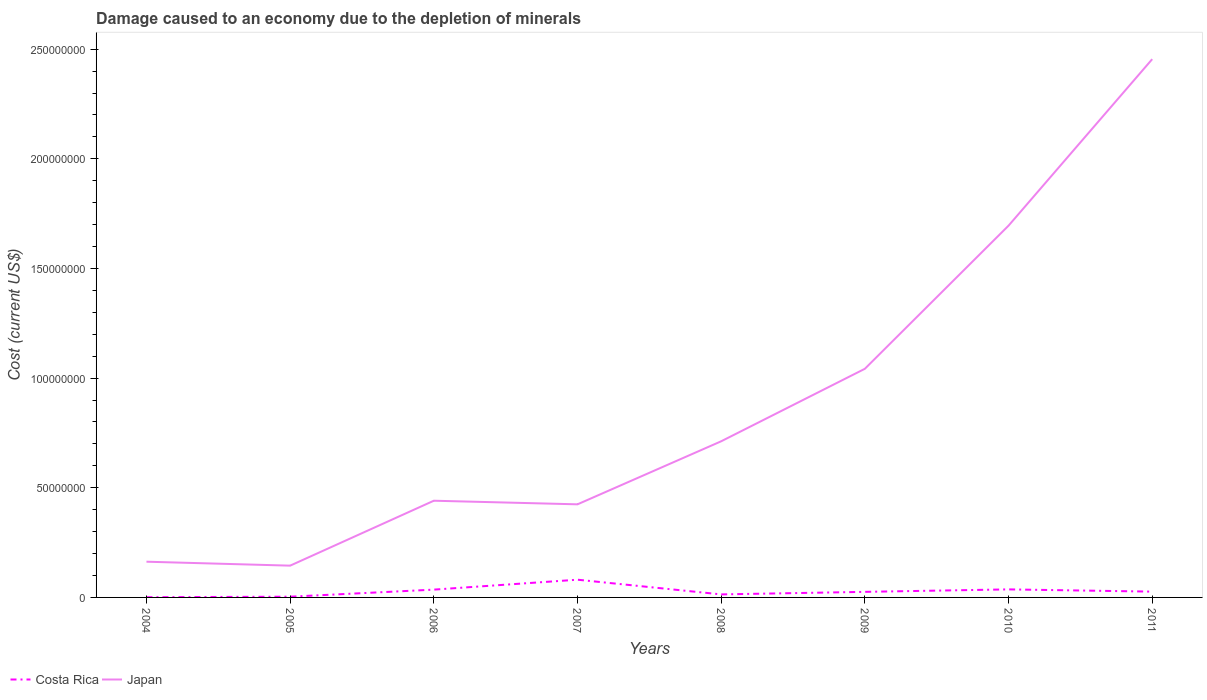Across all years, what is the maximum cost of damage caused due to the depletion of minerals in Costa Rica?
Offer a terse response. 1.03e+05. In which year was the cost of damage caused due to the depletion of minerals in Japan maximum?
Your answer should be very brief. 2005. What is the total cost of damage caused due to the depletion of minerals in Japan in the graph?
Your answer should be very brief. -2.31e+08. What is the difference between the highest and the second highest cost of damage caused due to the depletion of minerals in Japan?
Give a very brief answer. 2.31e+08. What is the difference between the highest and the lowest cost of damage caused due to the depletion of minerals in Japan?
Your answer should be very brief. 3. Is the cost of damage caused due to the depletion of minerals in Japan strictly greater than the cost of damage caused due to the depletion of minerals in Costa Rica over the years?
Offer a terse response. No. How many lines are there?
Offer a terse response. 2. How many years are there in the graph?
Make the answer very short. 8. Are the values on the major ticks of Y-axis written in scientific E-notation?
Keep it short and to the point. No. How many legend labels are there?
Your answer should be compact. 2. What is the title of the graph?
Give a very brief answer. Damage caused to an economy due to the depletion of minerals. Does "Morocco" appear as one of the legend labels in the graph?
Offer a very short reply. No. What is the label or title of the Y-axis?
Offer a terse response. Cost (current US$). What is the Cost (current US$) of Costa Rica in 2004?
Provide a succinct answer. 1.03e+05. What is the Cost (current US$) in Japan in 2004?
Provide a short and direct response. 1.63e+07. What is the Cost (current US$) of Costa Rica in 2005?
Ensure brevity in your answer.  3.34e+05. What is the Cost (current US$) of Japan in 2005?
Give a very brief answer. 1.45e+07. What is the Cost (current US$) of Costa Rica in 2006?
Offer a very short reply. 3.55e+06. What is the Cost (current US$) of Japan in 2006?
Provide a short and direct response. 4.41e+07. What is the Cost (current US$) in Costa Rica in 2007?
Provide a short and direct response. 8.08e+06. What is the Cost (current US$) of Japan in 2007?
Provide a short and direct response. 4.25e+07. What is the Cost (current US$) of Costa Rica in 2008?
Give a very brief answer. 1.38e+06. What is the Cost (current US$) in Japan in 2008?
Make the answer very short. 7.12e+07. What is the Cost (current US$) of Costa Rica in 2009?
Make the answer very short. 2.54e+06. What is the Cost (current US$) of Japan in 2009?
Offer a terse response. 1.04e+08. What is the Cost (current US$) of Costa Rica in 2010?
Your answer should be compact. 3.67e+06. What is the Cost (current US$) in Japan in 2010?
Offer a very short reply. 1.70e+08. What is the Cost (current US$) of Costa Rica in 2011?
Offer a very short reply. 2.64e+06. What is the Cost (current US$) in Japan in 2011?
Keep it short and to the point. 2.45e+08. Across all years, what is the maximum Cost (current US$) of Costa Rica?
Provide a succinct answer. 8.08e+06. Across all years, what is the maximum Cost (current US$) of Japan?
Ensure brevity in your answer.  2.45e+08. Across all years, what is the minimum Cost (current US$) of Costa Rica?
Offer a very short reply. 1.03e+05. Across all years, what is the minimum Cost (current US$) of Japan?
Provide a short and direct response. 1.45e+07. What is the total Cost (current US$) in Costa Rica in the graph?
Provide a succinct answer. 2.23e+07. What is the total Cost (current US$) of Japan in the graph?
Your response must be concise. 7.08e+08. What is the difference between the Cost (current US$) in Costa Rica in 2004 and that in 2005?
Offer a very short reply. -2.32e+05. What is the difference between the Cost (current US$) of Japan in 2004 and that in 2005?
Your answer should be very brief. 1.80e+06. What is the difference between the Cost (current US$) in Costa Rica in 2004 and that in 2006?
Your answer should be very brief. -3.45e+06. What is the difference between the Cost (current US$) of Japan in 2004 and that in 2006?
Your answer should be very brief. -2.78e+07. What is the difference between the Cost (current US$) of Costa Rica in 2004 and that in 2007?
Make the answer very short. -7.98e+06. What is the difference between the Cost (current US$) in Japan in 2004 and that in 2007?
Your answer should be compact. -2.62e+07. What is the difference between the Cost (current US$) in Costa Rica in 2004 and that in 2008?
Offer a terse response. -1.28e+06. What is the difference between the Cost (current US$) of Japan in 2004 and that in 2008?
Provide a succinct answer. -5.49e+07. What is the difference between the Cost (current US$) in Costa Rica in 2004 and that in 2009?
Offer a terse response. -2.44e+06. What is the difference between the Cost (current US$) in Japan in 2004 and that in 2009?
Offer a very short reply. -8.80e+07. What is the difference between the Cost (current US$) of Costa Rica in 2004 and that in 2010?
Your response must be concise. -3.57e+06. What is the difference between the Cost (current US$) of Japan in 2004 and that in 2010?
Your answer should be very brief. -1.53e+08. What is the difference between the Cost (current US$) in Costa Rica in 2004 and that in 2011?
Make the answer very short. -2.54e+06. What is the difference between the Cost (current US$) of Japan in 2004 and that in 2011?
Keep it short and to the point. -2.29e+08. What is the difference between the Cost (current US$) of Costa Rica in 2005 and that in 2006?
Your answer should be very brief. -3.22e+06. What is the difference between the Cost (current US$) in Japan in 2005 and that in 2006?
Provide a short and direct response. -2.96e+07. What is the difference between the Cost (current US$) in Costa Rica in 2005 and that in 2007?
Your response must be concise. -7.75e+06. What is the difference between the Cost (current US$) of Japan in 2005 and that in 2007?
Give a very brief answer. -2.80e+07. What is the difference between the Cost (current US$) in Costa Rica in 2005 and that in 2008?
Keep it short and to the point. -1.04e+06. What is the difference between the Cost (current US$) of Japan in 2005 and that in 2008?
Ensure brevity in your answer.  -5.67e+07. What is the difference between the Cost (current US$) of Costa Rica in 2005 and that in 2009?
Make the answer very short. -2.21e+06. What is the difference between the Cost (current US$) in Japan in 2005 and that in 2009?
Give a very brief answer. -8.98e+07. What is the difference between the Cost (current US$) in Costa Rica in 2005 and that in 2010?
Make the answer very short. -3.33e+06. What is the difference between the Cost (current US$) in Japan in 2005 and that in 2010?
Keep it short and to the point. -1.55e+08. What is the difference between the Cost (current US$) of Costa Rica in 2005 and that in 2011?
Your answer should be very brief. -2.31e+06. What is the difference between the Cost (current US$) in Japan in 2005 and that in 2011?
Your answer should be compact. -2.31e+08. What is the difference between the Cost (current US$) of Costa Rica in 2006 and that in 2007?
Provide a succinct answer. -4.53e+06. What is the difference between the Cost (current US$) of Japan in 2006 and that in 2007?
Offer a terse response. 1.64e+06. What is the difference between the Cost (current US$) in Costa Rica in 2006 and that in 2008?
Offer a very short reply. 2.18e+06. What is the difference between the Cost (current US$) in Japan in 2006 and that in 2008?
Your response must be concise. -2.71e+07. What is the difference between the Cost (current US$) in Costa Rica in 2006 and that in 2009?
Give a very brief answer. 1.01e+06. What is the difference between the Cost (current US$) in Japan in 2006 and that in 2009?
Your answer should be very brief. -6.02e+07. What is the difference between the Cost (current US$) in Costa Rica in 2006 and that in 2010?
Make the answer very short. -1.14e+05. What is the difference between the Cost (current US$) in Japan in 2006 and that in 2010?
Offer a terse response. -1.25e+08. What is the difference between the Cost (current US$) in Costa Rica in 2006 and that in 2011?
Provide a short and direct response. 9.13e+05. What is the difference between the Cost (current US$) in Japan in 2006 and that in 2011?
Offer a very short reply. -2.01e+08. What is the difference between the Cost (current US$) in Costa Rica in 2007 and that in 2008?
Make the answer very short. 6.70e+06. What is the difference between the Cost (current US$) in Japan in 2007 and that in 2008?
Provide a short and direct response. -2.87e+07. What is the difference between the Cost (current US$) in Costa Rica in 2007 and that in 2009?
Offer a very short reply. 5.54e+06. What is the difference between the Cost (current US$) of Japan in 2007 and that in 2009?
Your response must be concise. -6.18e+07. What is the difference between the Cost (current US$) in Costa Rica in 2007 and that in 2010?
Keep it short and to the point. 4.41e+06. What is the difference between the Cost (current US$) in Japan in 2007 and that in 2010?
Your answer should be very brief. -1.27e+08. What is the difference between the Cost (current US$) in Costa Rica in 2007 and that in 2011?
Ensure brevity in your answer.  5.44e+06. What is the difference between the Cost (current US$) of Japan in 2007 and that in 2011?
Offer a very short reply. -2.03e+08. What is the difference between the Cost (current US$) of Costa Rica in 2008 and that in 2009?
Provide a succinct answer. -1.16e+06. What is the difference between the Cost (current US$) in Japan in 2008 and that in 2009?
Your response must be concise. -3.31e+07. What is the difference between the Cost (current US$) of Costa Rica in 2008 and that in 2010?
Give a very brief answer. -2.29e+06. What is the difference between the Cost (current US$) in Japan in 2008 and that in 2010?
Provide a succinct answer. -9.83e+07. What is the difference between the Cost (current US$) in Costa Rica in 2008 and that in 2011?
Give a very brief answer. -1.26e+06. What is the difference between the Cost (current US$) in Japan in 2008 and that in 2011?
Your response must be concise. -1.74e+08. What is the difference between the Cost (current US$) in Costa Rica in 2009 and that in 2010?
Offer a terse response. -1.13e+06. What is the difference between the Cost (current US$) of Japan in 2009 and that in 2010?
Make the answer very short. -6.53e+07. What is the difference between the Cost (current US$) in Costa Rica in 2009 and that in 2011?
Make the answer very short. -1.02e+05. What is the difference between the Cost (current US$) in Japan in 2009 and that in 2011?
Provide a succinct answer. -1.41e+08. What is the difference between the Cost (current US$) in Costa Rica in 2010 and that in 2011?
Your response must be concise. 1.03e+06. What is the difference between the Cost (current US$) of Japan in 2010 and that in 2011?
Your response must be concise. -7.59e+07. What is the difference between the Cost (current US$) of Costa Rica in 2004 and the Cost (current US$) of Japan in 2005?
Your response must be concise. -1.44e+07. What is the difference between the Cost (current US$) of Costa Rica in 2004 and the Cost (current US$) of Japan in 2006?
Provide a succinct answer. -4.40e+07. What is the difference between the Cost (current US$) of Costa Rica in 2004 and the Cost (current US$) of Japan in 2007?
Provide a short and direct response. -4.23e+07. What is the difference between the Cost (current US$) of Costa Rica in 2004 and the Cost (current US$) of Japan in 2008?
Provide a short and direct response. -7.11e+07. What is the difference between the Cost (current US$) in Costa Rica in 2004 and the Cost (current US$) in Japan in 2009?
Offer a very short reply. -1.04e+08. What is the difference between the Cost (current US$) of Costa Rica in 2004 and the Cost (current US$) of Japan in 2010?
Provide a short and direct response. -1.69e+08. What is the difference between the Cost (current US$) in Costa Rica in 2004 and the Cost (current US$) in Japan in 2011?
Your response must be concise. -2.45e+08. What is the difference between the Cost (current US$) of Costa Rica in 2005 and the Cost (current US$) of Japan in 2006?
Your response must be concise. -4.38e+07. What is the difference between the Cost (current US$) of Costa Rica in 2005 and the Cost (current US$) of Japan in 2007?
Your answer should be very brief. -4.21e+07. What is the difference between the Cost (current US$) in Costa Rica in 2005 and the Cost (current US$) in Japan in 2008?
Give a very brief answer. -7.09e+07. What is the difference between the Cost (current US$) in Costa Rica in 2005 and the Cost (current US$) in Japan in 2009?
Keep it short and to the point. -1.04e+08. What is the difference between the Cost (current US$) in Costa Rica in 2005 and the Cost (current US$) in Japan in 2010?
Ensure brevity in your answer.  -1.69e+08. What is the difference between the Cost (current US$) of Costa Rica in 2005 and the Cost (current US$) of Japan in 2011?
Provide a short and direct response. -2.45e+08. What is the difference between the Cost (current US$) in Costa Rica in 2006 and the Cost (current US$) in Japan in 2007?
Your answer should be very brief. -3.89e+07. What is the difference between the Cost (current US$) of Costa Rica in 2006 and the Cost (current US$) of Japan in 2008?
Provide a short and direct response. -6.76e+07. What is the difference between the Cost (current US$) of Costa Rica in 2006 and the Cost (current US$) of Japan in 2009?
Provide a succinct answer. -1.01e+08. What is the difference between the Cost (current US$) of Costa Rica in 2006 and the Cost (current US$) of Japan in 2010?
Offer a very short reply. -1.66e+08. What is the difference between the Cost (current US$) in Costa Rica in 2006 and the Cost (current US$) in Japan in 2011?
Provide a short and direct response. -2.42e+08. What is the difference between the Cost (current US$) in Costa Rica in 2007 and the Cost (current US$) in Japan in 2008?
Ensure brevity in your answer.  -6.31e+07. What is the difference between the Cost (current US$) in Costa Rica in 2007 and the Cost (current US$) in Japan in 2009?
Give a very brief answer. -9.62e+07. What is the difference between the Cost (current US$) in Costa Rica in 2007 and the Cost (current US$) in Japan in 2010?
Ensure brevity in your answer.  -1.61e+08. What is the difference between the Cost (current US$) of Costa Rica in 2007 and the Cost (current US$) of Japan in 2011?
Provide a short and direct response. -2.37e+08. What is the difference between the Cost (current US$) of Costa Rica in 2008 and the Cost (current US$) of Japan in 2009?
Your answer should be compact. -1.03e+08. What is the difference between the Cost (current US$) in Costa Rica in 2008 and the Cost (current US$) in Japan in 2010?
Keep it short and to the point. -1.68e+08. What is the difference between the Cost (current US$) in Costa Rica in 2008 and the Cost (current US$) in Japan in 2011?
Make the answer very short. -2.44e+08. What is the difference between the Cost (current US$) of Costa Rica in 2009 and the Cost (current US$) of Japan in 2010?
Provide a short and direct response. -1.67e+08. What is the difference between the Cost (current US$) in Costa Rica in 2009 and the Cost (current US$) in Japan in 2011?
Provide a short and direct response. -2.43e+08. What is the difference between the Cost (current US$) in Costa Rica in 2010 and the Cost (current US$) in Japan in 2011?
Keep it short and to the point. -2.42e+08. What is the average Cost (current US$) of Costa Rica per year?
Keep it short and to the point. 2.79e+06. What is the average Cost (current US$) of Japan per year?
Ensure brevity in your answer.  8.85e+07. In the year 2004, what is the difference between the Cost (current US$) in Costa Rica and Cost (current US$) in Japan?
Your response must be concise. -1.62e+07. In the year 2005, what is the difference between the Cost (current US$) of Costa Rica and Cost (current US$) of Japan?
Give a very brief answer. -1.42e+07. In the year 2006, what is the difference between the Cost (current US$) of Costa Rica and Cost (current US$) of Japan?
Your answer should be compact. -4.05e+07. In the year 2007, what is the difference between the Cost (current US$) in Costa Rica and Cost (current US$) in Japan?
Keep it short and to the point. -3.44e+07. In the year 2008, what is the difference between the Cost (current US$) of Costa Rica and Cost (current US$) of Japan?
Keep it short and to the point. -6.98e+07. In the year 2009, what is the difference between the Cost (current US$) in Costa Rica and Cost (current US$) in Japan?
Ensure brevity in your answer.  -1.02e+08. In the year 2010, what is the difference between the Cost (current US$) of Costa Rica and Cost (current US$) of Japan?
Ensure brevity in your answer.  -1.66e+08. In the year 2011, what is the difference between the Cost (current US$) of Costa Rica and Cost (current US$) of Japan?
Make the answer very short. -2.43e+08. What is the ratio of the Cost (current US$) in Costa Rica in 2004 to that in 2005?
Provide a short and direct response. 0.31. What is the ratio of the Cost (current US$) of Japan in 2004 to that in 2005?
Give a very brief answer. 1.12. What is the ratio of the Cost (current US$) of Costa Rica in 2004 to that in 2006?
Provide a short and direct response. 0.03. What is the ratio of the Cost (current US$) in Japan in 2004 to that in 2006?
Your answer should be compact. 0.37. What is the ratio of the Cost (current US$) of Costa Rica in 2004 to that in 2007?
Make the answer very short. 0.01. What is the ratio of the Cost (current US$) in Japan in 2004 to that in 2007?
Your response must be concise. 0.38. What is the ratio of the Cost (current US$) in Costa Rica in 2004 to that in 2008?
Provide a short and direct response. 0.07. What is the ratio of the Cost (current US$) in Japan in 2004 to that in 2008?
Keep it short and to the point. 0.23. What is the ratio of the Cost (current US$) of Costa Rica in 2004 to that in 2009?
Your answer should be compact. 0.04. What is the ratio of the Cost (current US$) in Japan in 2004 to that in 2009?
Your answer should be very brief. 0.16. What is the ratio of the Cost (current US$) of Costa Rica in 2004 to that in 2010?
Offer a terse response. 0.03. What is the ratio of the Cost (current US$) in Japan in 2004 to that in 2010?
Offer a terse response. 0.1. What is the ratio of the Cost (current US$) of Costa Rica in 2004 to that in 2011?
Your answer should be compact. 0.04. What is the ratio of the Cost (current US$) of Japan in 2004 to that in 2011?
Offer a very short reply. 0.07. What is the ratio of the Cost (current US$) in Costa Rica in 2005 to that in 2006?
Ensure brevity in your answer.  0.09. What is the ratio of the Cost (current US$) in Japan in 2005 to that in 2006?
Give a very brief answer. 0.33. What is the ratio of the Cost (current US$) in Costa Rica in 2005 to that in 2007?
Your answer should be compact. 0.04. What is the ratio of the Cost (current US$) of Japan in 2005 to that in 2007?
Your answer should be very brief. 0.34. What is the ratio of the Cost (current US$) in Costa Rica in 2005 to that in 2008?
Your response must be concise. 0.24. What is the ratio of the Cost (current US$) of Japan in 2005 to that in 2008?
Provide a short and direct response. 0.2. What is the ratio of the Cost (current US$) of Costa Rica in 2005 to that in 2009?
Offer a terse response. 0.13. What is the ratio of the Cost (current US$) in Japan in 2005 to that in 2009?
Provide a short and direct response. 0.14. What is the ratio of the Cost (current US$) in Costa Rica in 2005 to that in 2010?
Offer a terse response. 0.09. What is the ratio of the Cost (current US$) in Japan in 2005 to that in 2010?
Offer a very short reply. 0.09. What is the ratio of the Cost (current US$) in Costa Rica in 2005 to that in 2011?
Offer a very short reply. 0.13. What is the ratio of the Cost (current US$) of Japan in 2005 to that in 2011?
Offer a very short reply. 0.06. What is the ratio of the Cost (current US$) in Costa Rica in 2006 to that in 2007?
Provide a succinct answer. 0.44. What is the ratio of the Cost (current US$) of Japan in 2006 to that in 2007?
Your response must be concise. 1.04. What is the ratio of the Cost (current US$) in Costa Rica in 2006 to that in 2008?
Ensure brevity in your answer.  2.58. What is the ratio of the Cost (current US$) in Japan in 2006 to that in 2008?
Offer a terse response. 0.62. What is the ratio of the Cost (current US$) of Costa Rica in 2006 to that in 2009?
Your response must be concise. 1.4. What is the ratio of the Cost (current US$) in Japan in 2006 to that in 2009?
Provide a succinct answer. 0.42. What is the ratio of the Cost (current US$) in Costa Rica in 2006 to that in 2010?
Provide a short and direct response. 0.97. What is the ratio of the Cost (current US$) in Japan in 2006 to that in 2010?
Make the answer very short. 0.26. What is the ratio of the Cost (current US$) of Costa Rica in 2006 to that in 2011?
Keep it short and to the point. 1.35. What is the ratio of the Cost (current US$) in Japan in 2006 to that in 2011?
Make the answer very short. 0.18. What is the ratio of the Cost (current US$) in Costa Rica in 2007 to that in 2008?
Offer a very short reply. 5.86. What is the ratio of the Cost (current US$) of Japan in 2007 to that in 2008?
Ensure brevity in your answer.  0.6. What is the ratio of the Cost (current US$) in Costa Rica in 2007 to that in 2009?
Keep it short and to the point. 3.18. What is the ratio of the Cost (current US$) in Japan in 2007 to that in 2009?
Ensure brevity in your answer.  0.41. What is the ratio of the Cost (current US$) of Costa Rica in 2007 to that in 2010?
Keep it short and to the point. 2.2. What is the ratio of the Cost (current US$) in Japan in 2007 to that in 2010?
Ensure brevity in your answer.  0.25. What is the ratio of the Cost (current US$) of Costa Rica in 2007 to that in 2011?
Provide a succinct answer. 3.06. What is the ratio of the Cost (current US$) of Japan in 2007 to that in 2011?
Your answer should be very brief. 0.17. What is the ratio of the Cost (current US$) of Costa Rica in 2008 to that in 2009?
Ensure brevity in your answer.  0.54. What is the ratio of the Cost (current US$) in Japan in 2008 to that in 2009?
Keep it short and to the point. 0.68. What is the ratio of the Cost (current US$) of Costa Rica in 2008 to that in 2010?
Provide a short and direct response. 0.38. What is the ratio of the Cost (current US$) in Japan in 2008 to that in 2010?
Offer a very short reply. 0.42. What is the ratio of the Cost (current US$) in Costa Rica in 2008 to that in 2011?
Provide a short and direct response. 0.52. What is the ratio of the Cost (current US$) in Japan in 2008 to that in 2011?
Offer a terse response. 0.29. What is the ratio of the Cost (current US$) in Costa Rica in 2009 to that in 2010?
Ensure brevity in your answer.  0.69. What is the ratio of the Cost (current US$) in Japan in 2009 to that in 2010?
Make the answer very short. 0.61. What is the ratio of the Cost (current US$) in Costa Rica in 2009 to that in 2011?
Keep it short and to the point. 0.96. What is the ratio of the Cost (current US$) in Japan in 2009 to that in 2011?
Provide a short and direct response. 0.42. What is the ratio of the Cost (current US$) of Costa Rica in 2010 to that in 2011?
Provide a succinct answer. 1.39. What is the ratio of the Cost (current US$) of Japan in 2010 to that in 2011?
Make the answer very short. 0.69. What is the difference between the highest and the second highest Cost (current US$) in Costa Rica?
Make the answer very short. 4.41e+06. What is the difference between the highest and the second highest Cost (current US$) in Japan?
Your answer should be very brief. 7.59e+07. What is the difference between the highest and the lowest Cost (current US$) in Costa Rica?
Your answer should be compact. 7.98e+06. What is the difference between the highest and the lowest Cost (current US$) of Japan?
Make the answer very short. 2.31e+08. 